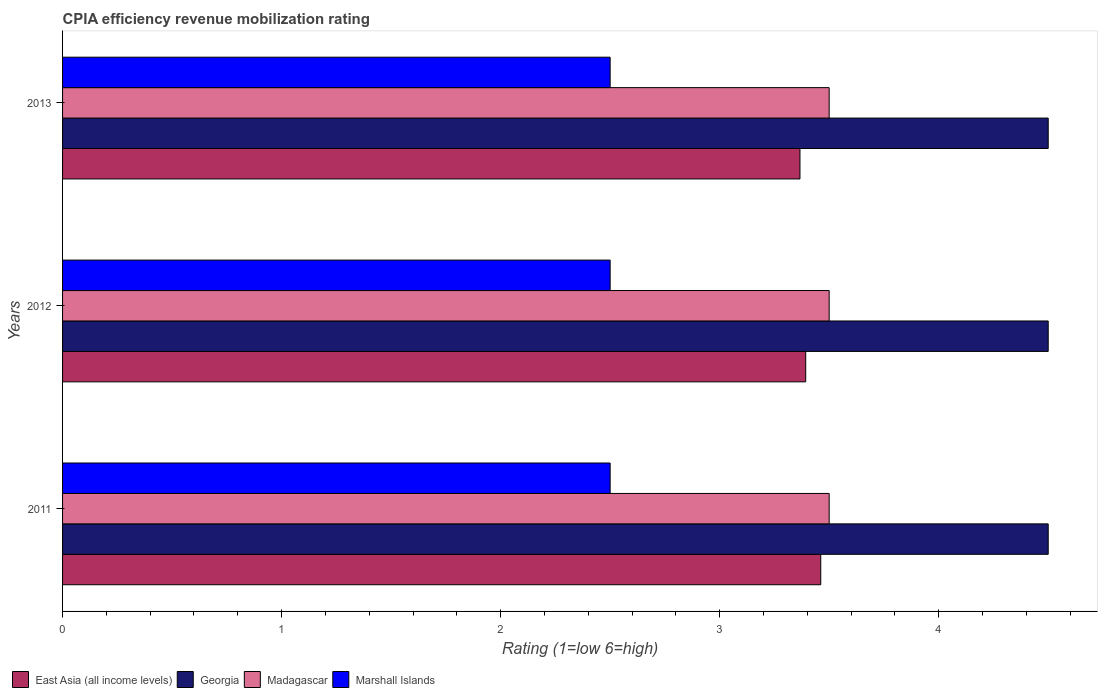Are the number of bars on each tick of the Y-axis equal?
Offer a terse response. Yes. What is the CPIA rating in Madagascar in 2013?
Offer a very short reply. 3.5. Across all years, what is the maximum CPIA rating in East Asia (all income levels)?
Make the answer very short. 3.46. Across all years, what is the minimum CPIA rating in East Asia (all income levels)?
Give a very brief answer. 3.37. In which year was the CPIA rating in East Asia (all income levels) maximum?
Offer a very short reply. 2011. What is the total CPIA rating in Georgia in the graph?
Your answer should be very brief. 13.5. What is the difference between the CPIA rating in Georgia in 2011 and that in 2013?
Your answer should be compact. 0. What is the difference between the CPIA rating in Madagascar in 2011 and the CPIA rating in East Asia (all income levels) in 2012?
Your answer should be very brief. 0.11. What is the average CPIA rating in Madagascar per year?
Your answer should be compact. 3.5. In how many years, is the CPIA rating in Marshall Islands greater than 0.8 ?
Offer a very short reply. 3. What is the ratio of the CPIA rating in Madagascar in 2011 to that in 2012?
Give a very brief answer. 1. Is the CPIA rating in East Asia (all income levels) in 2011 less than that in 2012?
Offer a terse response. No. In how many years, is the CPIA rating in Marshall Islands greater than the average CPIA rating in Marshall Islands taken over all years?
Provide a short and direct response. 0. Is the sum of the CPIA rating in Madagascar in 2011 and 2012 greater than the maximum CPIA rating in East Asia (all income levels) across all years?
Ensure brevity in your answer.  Yes. What does the 2nd bar from the top in 2011 represents?
Provide a short and direct response. Madagascar. What does the 4th bar from the bottom in 2013 represents?
Your response must be concise. Marshall Islands. Is it the case that in every year, the sum of the CPIA rating in East Asia (all income levels) and CPIA rating in Georgia is greater than the CPIA rating in Madagascar?
Make the answer very short. Yes. What is the difference between two consecutive major ticks on the X-axis?
Make the answer very short. 1. Does the graph contain any zero values?
Your response must be concise. No. Where does the legend appear in the graph?
Your answer should be compact. Bottom left. What is the title of the graph?
Keep it short and to the point. CPIA efficiency revenue mobilization rating. Does "Brunei Darussalam" appear as one of the legend labels in the graph?
Provide a succinct answer. No. What is the label or title of the X-axis?
Give a very brief answer. Rating (1=low 6=high). What is the Rating (1=low 6=high) of East Asia (all income levels) in 2011?
Provide a succinct answer. 3.46. What is the Rating (1=low 6=high) of Georgia in 2011?
Your answer should be very brief. 4.5. What is the Rating (1=low 6=high) in Marshall Islands in 2011?
Offer a terse response. 2.5. What is the Rating (1=low 6=high) of East Asia (all income levels) in 2012?
Make the answer very short. 3.39. What is the Rating (1=low 6=high) of Georgia in 2012?
Give a very brief answer. 4.5. What is the Rating (1=low 6=high) in Madagascar in 2012?
Offer a very short reply. 3.5. What is the Rating (1=low 6=high) in East Asia (all income levels) in 2013?
Keep it short and to the point. 3.37. What is the Rating (1=low 6=high) of Marshall Islands in 2013?
Offer a terse response. 2.5. Across all years, what is the maximum Rating (1=low 6=high) in East Asia (all income levels)?
Ensure brevity in your answer.  3.46. Across all years, what is the maximum Rating (1=low 6=high) in Marshall Islands?
Your answer should be very brief. 2.5. Across all years, what is the minimum Rating (1=low 6=high) in East Asia (all income levels)?
Your answer should be very brief. 3.37. What is the total Rating (1=low 6=high) of East Asia (all income levels) in the graph?
Keep it short and to the point. 10.22. What is the difference between the Rating (1=low 6=high) in East Asia (all income levels) in 2011 and that in 2012?
Make the answer very short. 0.07. What is the difference between the Rating (1=low 6=high) in Marshall Islands in 2011 and that in 2012?
Offer a very short reply. 0. What is the difference between the Rating (1=low 6=high) in East Asia (all income levels) in 2011 and that in 2013?
Your response must be concise. 0.09. What is the difference between the Rating (1=low 6=high) in Madagascar in 2011 and that in 2013?
Keep it short and to the point. 0. What is the difference between the Rating (1=low 6=high) in East Asia (all income levels) in 2012 and that in 2013?
Offer a terse response. 0.03. What is the difference between the Rating (1=low 6=high) of East Asia (all income levels) in 2011 and the Rating (1=low 6=high) of Georgia in 2012?
Offer a terse response. -1.04. What is the difference between the Rating (1=low 6=high) of East Asia (all income levels) in 2011 and the Rating (1=low 6=high) of Madagascar in 2012?
Your answer should be very brief. -0.04. What is the difference between the Rating (1=low 6=high) in East Asia (all income levels) in 2011 and the Rating (1=low 6=high) in Marshall Islands in 2012?
Offer a terse response. 0.96. What is the difference between the Rating (1=low 6=high) in Georgia in 2011 and the Rating (1=low 6=high) in Madagascar in 2012?
Ensure brevity in your answer.  1. What is the difference between the Rating (1=low 6=high) in East Asia (all income levels) in 2011 and the Rating (1=low 6=high) in Georgia in 2013?
Offer a terse response. -1.04. What is the difference between the Rating (1=low 6=high) of East Asia (all income levels) in 2011 and the Rating (1=low 6=high) of Madagascar in 2013?
Give a very brief answer. -0.04. What is the difference between the Rating (1=low 6=high) in East Asia (all income levels) in 2011 and the Rating (1=low 6=high) in Marshall Islands in 2013?
Your answer should be compact. 0.96. What is the difference between the Rating (1=low 6=high) in East Asia (all income levels) in 2012 and the Rating (1=low 6=high) in Georgia in 2013?
Your answer should be very brief. -1.11. What is the difference between the Rating (1=low 6=high) of East Asia (all income levels) in 2012 and the Rating (1=low 6=high) of Madagascar in 2013?
Your response must be concise. -0.11. What is the difference between the Rating (1=low 6=high) in East Asia (all income levels) in 2012 and the Rating (1=low 6=high) in Marshall Islands in 2013?
Give a very brief answer. 0.89. What is the difference between the Rating (1=low 6=high) in Georgia in 2012 and the Rating (1=low 6=high) in Madagascar in 2013?
Keep it short and to the point. 1. What is the difference between the Rating (1=low 6=high) in Georgia in 2012 and the Rating (1=low 6=high) in Marshall Islands in 2013?
Give a very brief answer. 2. What is the difference between the Rating (1=low 6=high) in Madagascar in 2012 and the Rating (1=low 6=high) in Marshall Islands in 2013?
Make the answer very short. 1. What is the average Rating (1=low 6=high) of East Asia (all income levels) per year?
Ensure brevity in your answer.  3.41. What is the average Rating (1=low 6=high) in Georgia per year?
Offer a very short reply. 4.5. What is the average Rating (1=low 6=high) of Madagascar per year?
Keep it short and to the point. 3.5. What is the average Rating (1=low 6=high) in Marshall Islands per year?
Give a very brief answer. 2.5. In the year 2011, what is the difference between the Rating (1=low 6=high) of East Asia (all income levels) and Rating (1=low 6=high) of Georgia?
Your answer should be very brief. -1.04. In the year 2011, what is the difference between the Rating (1=low 6=high) of East Asia (all income levels) and Rating (1=low 6=high) of Madagascar?
Provide a succinct answer. -0.04. In the year 2011, what is the difference between the Rating (1=low 6=high) in East Asia (all income levels) and Rating (1=low 6=high) in Marshall Islands?
Offer a terse response. 0.96. In the year 2012, what is the difference between the Rating (1=low 6=high) of East Asia (all income levels) and Rating (1=low 6=high) of Georgia?
Give a very brief answer. -1.11. In the year 2012, what is the difference between the Rating (1=low 6=high) of East Asia (all income levels) and Rating (1=low 6=high) of Madagascar?
Your answer should be very brief. -0.11. In the year 2012, what is the difference between the Rating (1=low 6=high) in East Asia (all income levels) and Rating (1=low 6=high) in Marshall Islands?
Ensure brevity in your answer.  0.89. In the year 2012, what is the difference between the Rating (1=low 6=high) of Georgia and Rating (1=low 6=high) of Madagascar?
Your answer should be very brief. 1. In the year 2012, what is the difference between the Rating (1=low 6=high) in Madagascar and Rating (1=low 6=high) in Marshall Islands?
Give a very brief answer. 1. In the year 2013, what is the difference between the Rating (1=low 6=high) of East Asia (all income levels) and Rating (1=low 6=high) of Georgia?
Provide a short and direct response. -1.13. In the year 2013, what is the difference between the Rating (1=low 6=high) in East Asia (all income levels) and Rating (1=low 6=high) in Madagascar?
Make the answer very short. -0.13. In the year 2013, what is the difference between the Rating (1=low 6=high) in East Asia (all income levels) and Rating (1=low 6=high) in Marshall Islands?
Give a very brief answer. 0.87. In the year 2013, what is the difference between the Rating (1=low 6=high) of Georgia and Rating (1=low 6=high) of Marshall Islands?
Make the answer very short. 2. In the year 2013, what is the difference between the Rating (1=low 6=high) in Madagascar and Rating (1=low 6=high) in Marshall Islands?
Make the answer very short. 1. What is the ratio of the Rating (1=low 6=high) of East Asia (all income levels) in 2011 to that in 2012?
Provide a succinct answer. 1.02. What is the ratio of the Rating (1=low 6=high) in Madagascar in 2011 to that in 2012?
Give a very brief answer. 1. What is the ratio of the Rating (1=low 6=high) of Marshall Islands in 2011 to that in 2012?
Offer a terse response. 1. What is the ratio of the Rating (1=low 6=high) in East Asia (all income levels) in 2011 to that in 2013?
Provide a short and direct response. 1.03. What is the ratio of the Rating (1=low 6=high) in Georgia in 2011 to that in 2013?
Offer a terse response. 1. What is the ratio of the Rating (1=low 6=high) in Madagascar in 2011 to that in 2013?
Your answer should be very brief. 1. What is the ratio of the Rating (1=low 6=high) of East Asia (all income levels) in 2012 to that in 2013?
Offer a terse response. 1.01. What is the ratio of the Rating (1=low 6=high) in Marshall Islands in 2012 to that in 2013?
Your response must be concise. 1. What is the difference between the highest and the second highest Rating (1=low 6=high) of East Asia (all income levels)?
Offer a terse response. 0.07. What is the difference between the highest and the second highest Rating (1=low 6=high) in Madagascar?
Provide a short and direct response. 0. What is the difference between the highest and the second highest Rating (1=low 6=high) in Marshall Islands?
Provide a succinct answer. 0. What is the difference between the highest and the lowest Rating (1=low 6=high) of East Asia (all income levels)?
Give a very brief answer. 0.09. What is the difference between the highest and the lowest Rating (1=low 6=high) in Georgia?
Your answer should be very brief. 0. What is the difference between the highest and the lowest Rating (1=low 6=high) of Madagascar?
Your answer should be compact. 0. What is the difference between the highest and the lowest Rating (1=low 6=high) of Marshall Islands?
Ensure brevity in your answer.  0. 